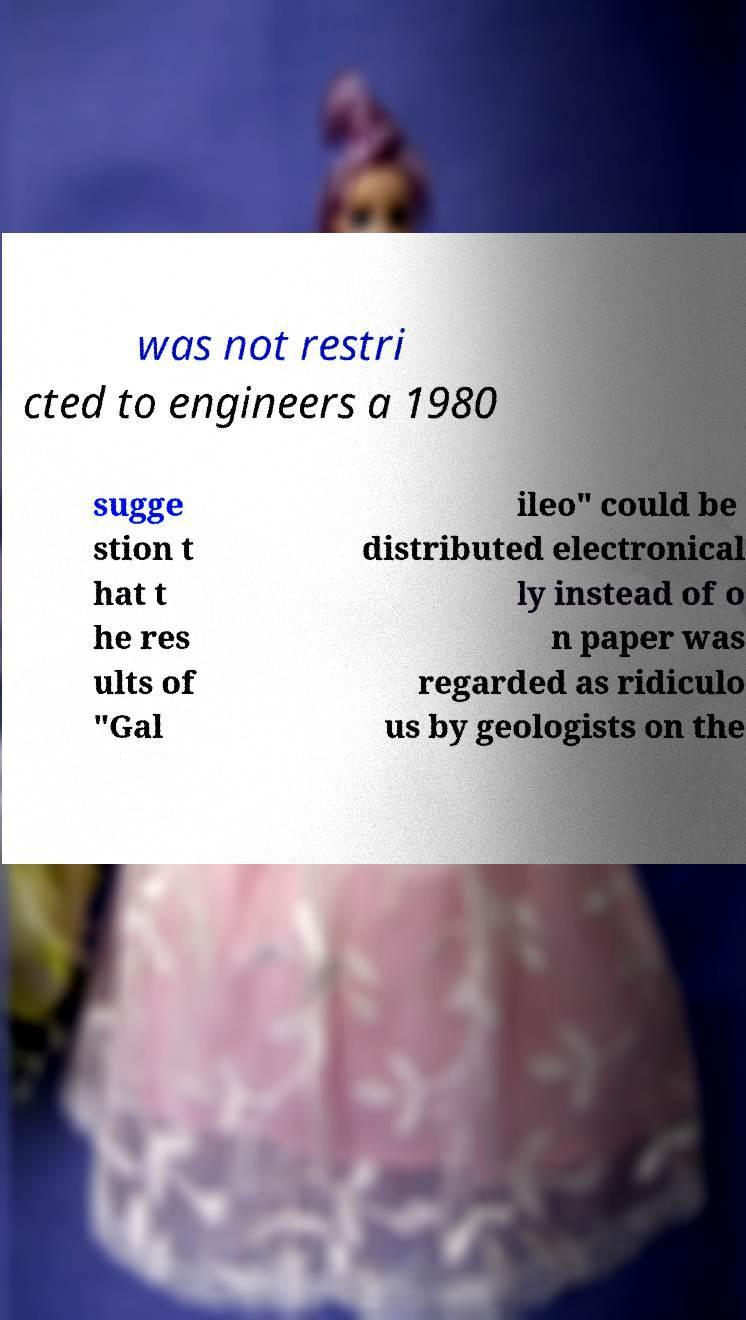Please identify and transcribe the text found in this image. was not restri cted to engineers a 1980 sugge stion t hat t he res ults of "Gal ileo" could be distributed electronical ly instead of o n paper was regarded as ridiculo us by geologists on the 